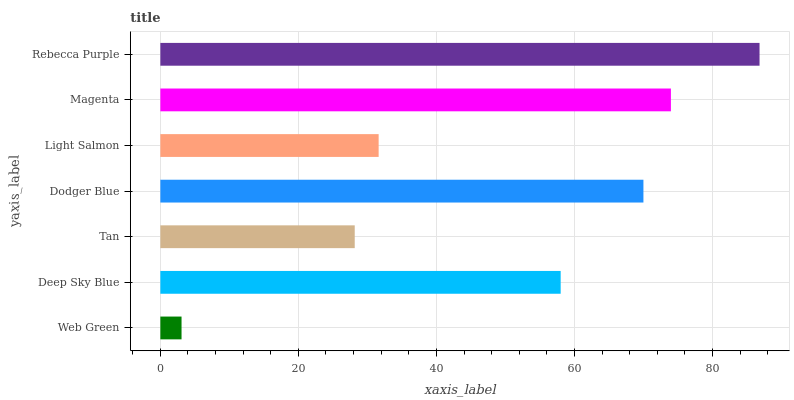Is Web Green the minimum?
Answer yes or no. Yes. Is Rebecca Purple the maximum?
Answer yes or no. Yes. Is Deep Sky Blue the minimum?
Answer yes or no. No. Is Deep Sky Blue the maximum?
Answer yes or no. No. Is Deep Sky Blue greater than Web Green?
Answer yes or no. Yes. Is Web Green less than Deep Sky Blue?
Answer yes or no. Yes. Is Web Green greater than Deep Sky Blue?
Answer yes or no. No. Is Deep Sky Blue less than Web Green?
Answer yes or no. No. Is Deep Sky Blue the high median?
Answer yes or no. Yes. Is Deep Sky Blue the low median?
Answer yes or no. Yes. Is Web Green the high median?
Answer yes or no. No. Is Magenta the low median?
Answer yes or no. No. 